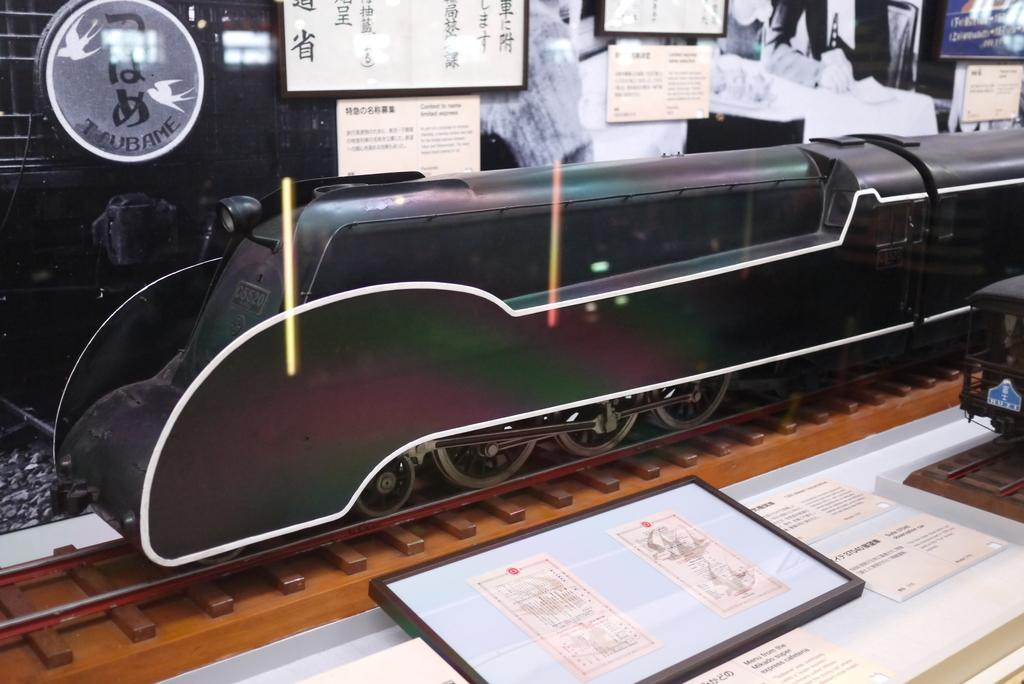What is the main subject of the picture? The main subject of the picture is a toy train. What else can be seen around the toy train? There are papers and notes around the toy train. Are there any other objects present in the image? Yes, there are other objects present in the image. Can you tell me how many monkeys are sitting on the toy train in the image? There are no monkeys present in the image; it features a toy train with papers and notes around it. What type of fog can be seen in the image? There is no fog present in the image. 